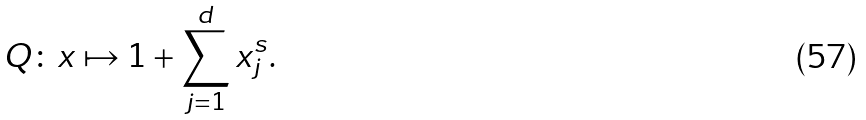Convert formula to latex. <formula><loc_0><loc_0><loc_500><loc_500>Q \colon x \mapsto 1 + \sum _ { j = 1 } ^ { d } x _ { j } ^ { s } .</formula> 